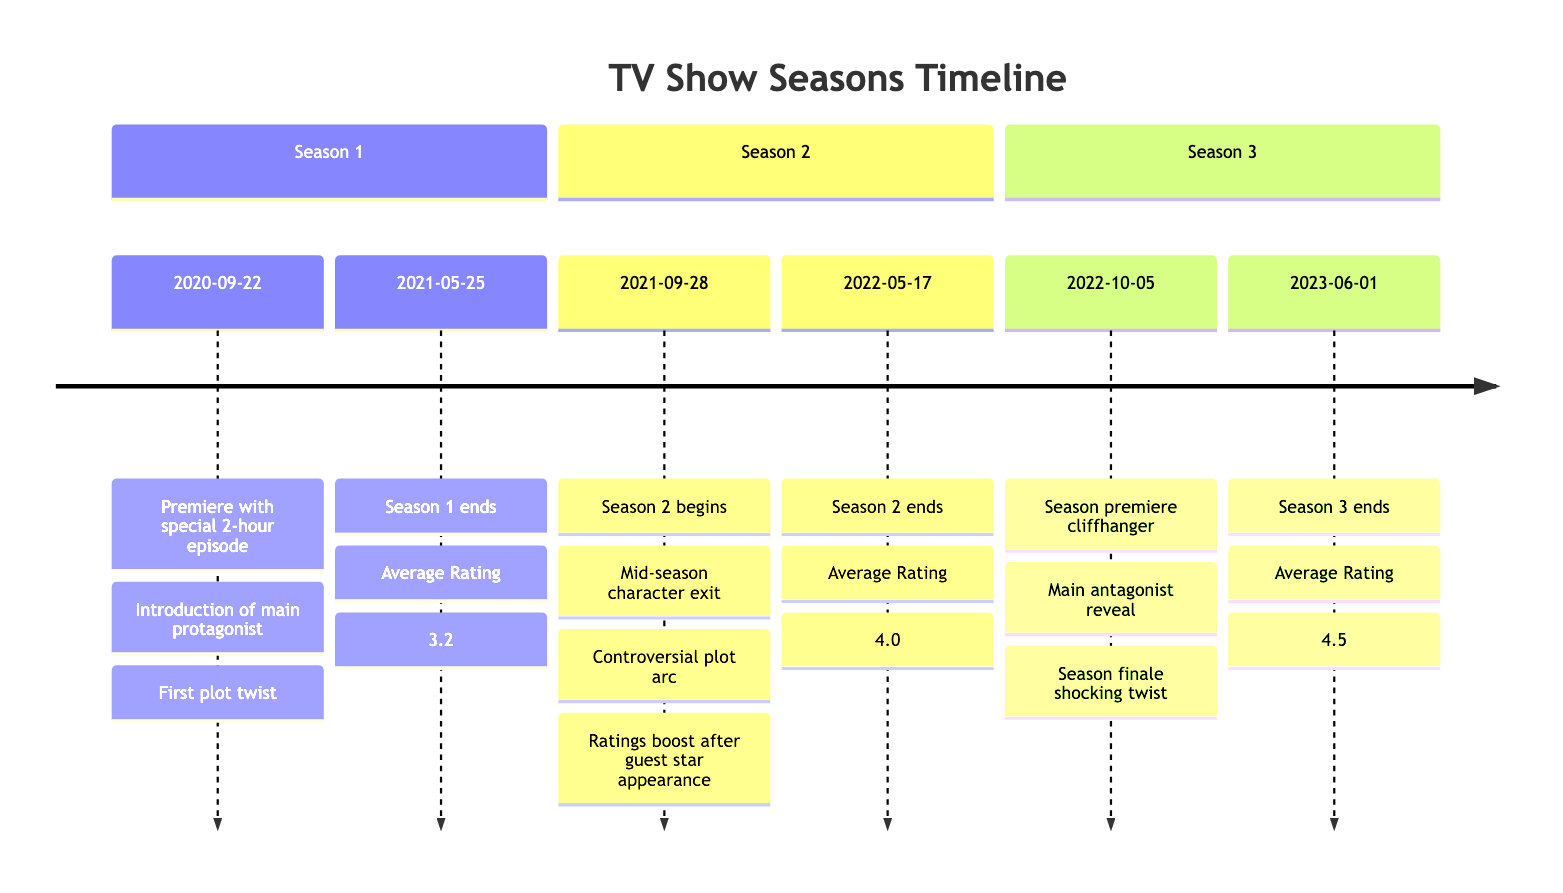What is the average rating for Season 1? The diagram states that Season 1 has an average rating of 3.2. This information can be found at the end of the section for Season 1 in the timeline.
Answer: 3.2 How many key events occurred in Season 2? The diagram lists three key events for Season 2: Mid-season character exit, Controversial plot arc, and Ratings boost after guest star appearance. Thus, there are three key events.
Answer: 3 Which season had the highest average rating? By comparing the average ratings of all three seasons (3.2, 4.0, and 4.5), Season 3 has the highest average rating at 4.5, which is indicated in its section at the end.
Answer: 4.5 What is the percentage of viewers aged 25 to 34 in Season 3? According to the viewer demographics mentioned for Season 3, the percentage of viewers aged 25 to 34 is 25%. This demographic is represented in the data for that particular season.
Answer: 25% Did the percentage of male viewers increase or decrease from Season 1 to Season 3? In Season 1, 55% of viewers were male, while in Season 3, this percentage was 50%. This indicates a decrease in the percentage of male viewers from the first to the third season. Thus, it can be concluded that there was a decrease.
Answer: Decrease What key event marks the beginning of Season 3? The beginning of Season 3 is marked by the event "Season premiere cliffhanger," which is the first event listed under the Season 3 section.
Answer: Season premiere cliffhanger What was the average rating change from Season 2 to Season 3? The average rating for Season 2 is 4.0 and for Season 3 it is 4.5. The change can be calculated by subtracting the average rating of Season 2 from that of Season 3: 4.5 - 4.0 equals a change of 0.5.
Answer: 0.5 What percentage of Season 2's viewers were 50 years or older? In Season 2, the viewer demographic of those aged 50 plus is provided as 27%. This specific demographic is included in the viewer demographic section for Season 2.
Answer: 27% 